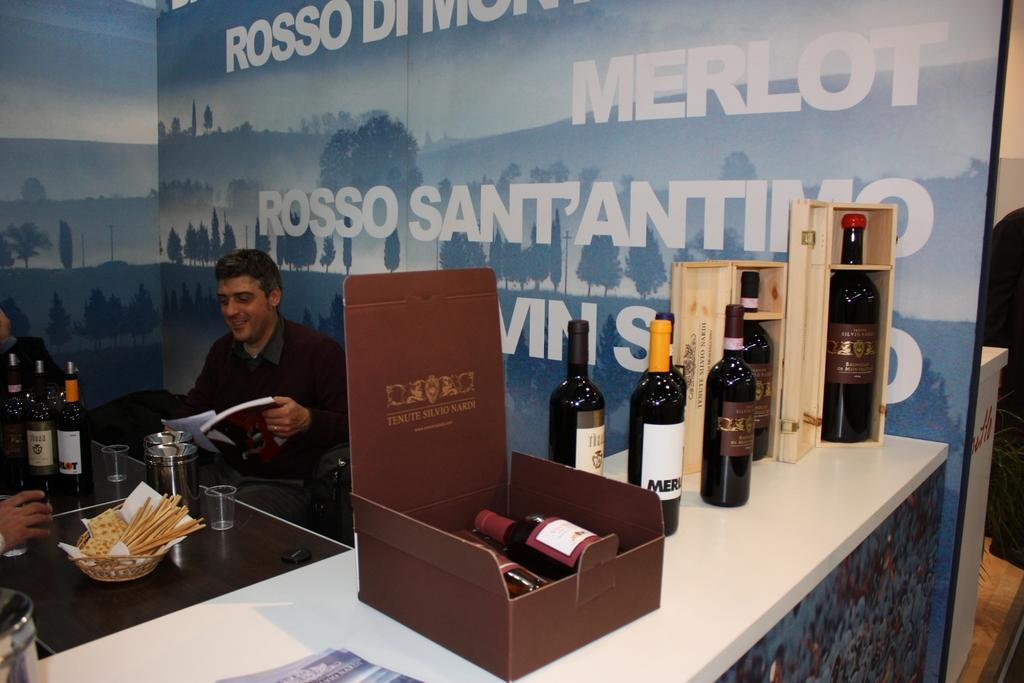<image>
Summarize the visual content of the image. a few people sitting down with a merlot sign near them 